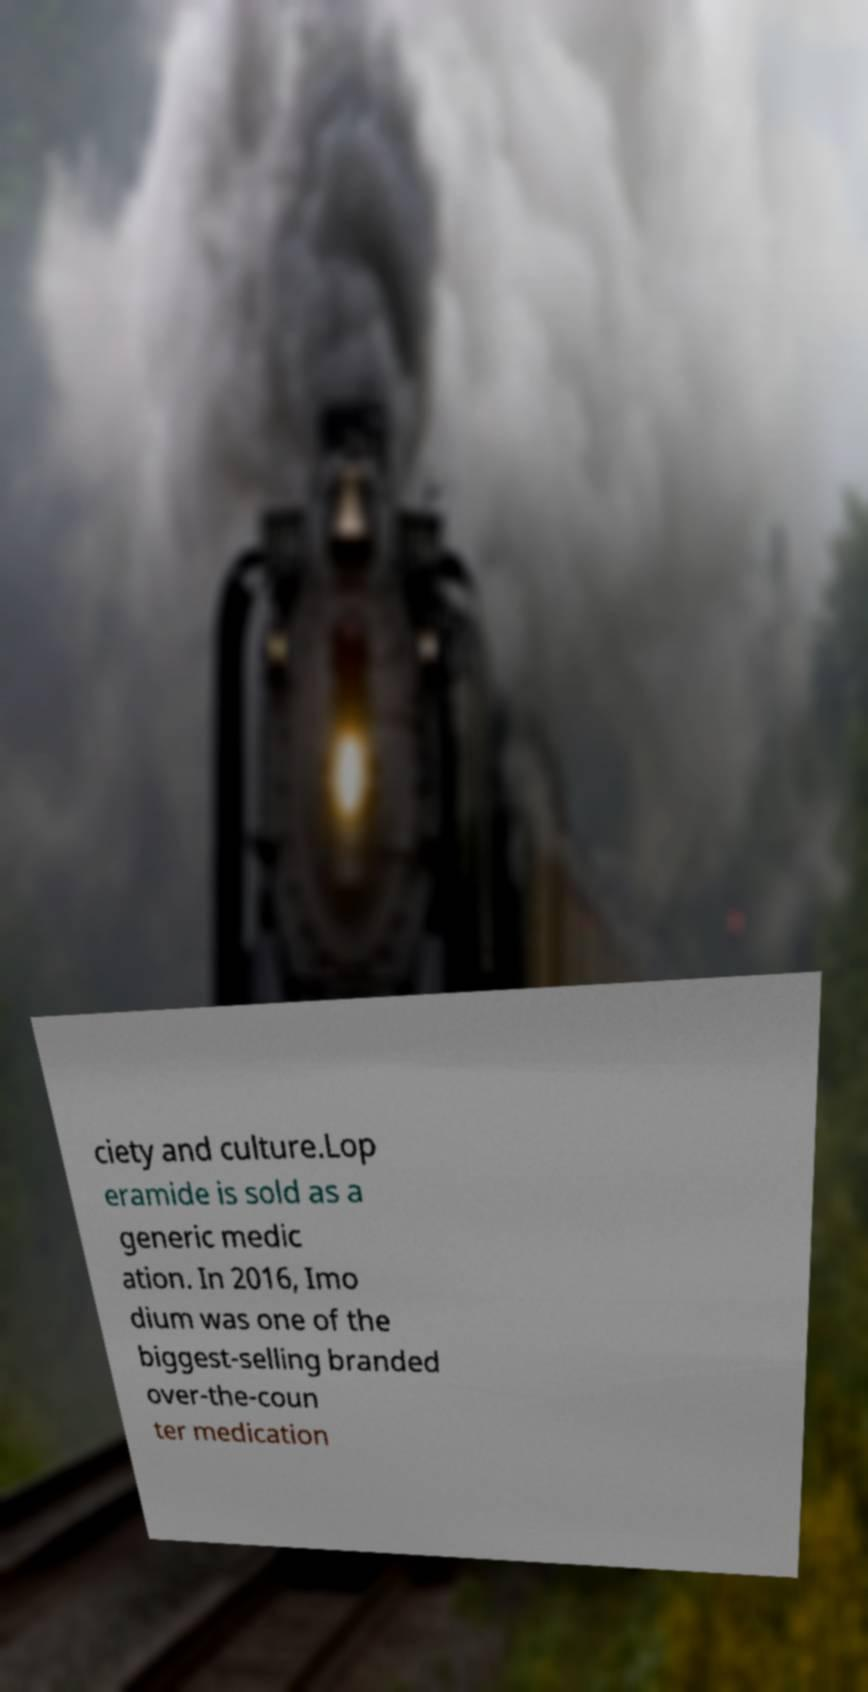There's text embedded in this image that I need extracted. Can you transcribe it verbatim? ciety and culture.Lop eramide is sold as a generic medic ation. In 2016, Imo dium was one of the biggest-selling branded over-the-coun ter medication 